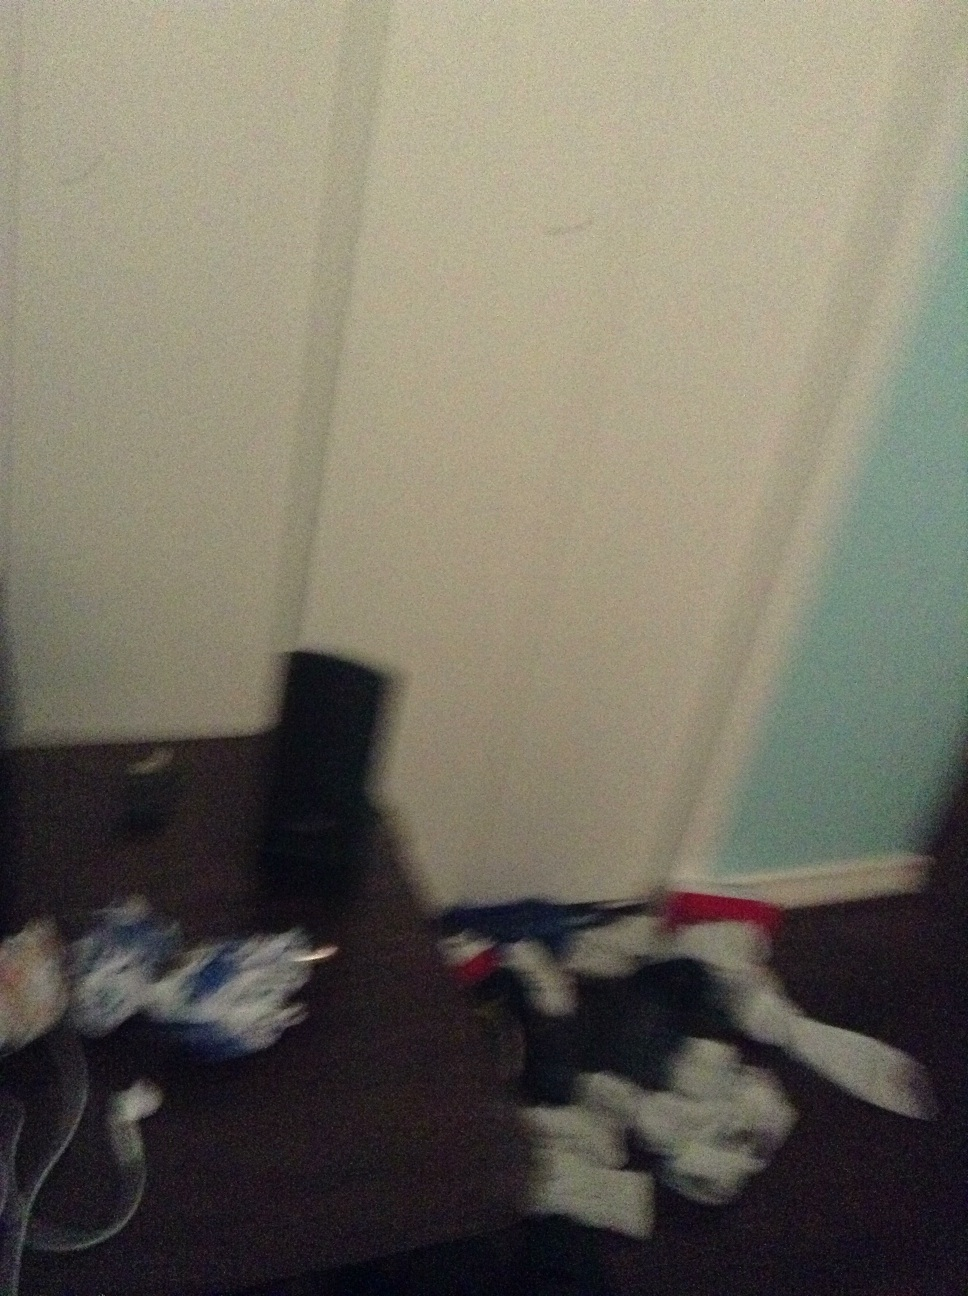What is this? from Vizwiz It’s challenging to provide specific details due to the blurriness and poor lighting of the image, but it appears to show a cluttered room. There might be some speakers or electronic equipment in the background, as well as scattered items that could include clothing or papers. Given the quality and angle of the photo, a more precise description is difficult to ascertain. 